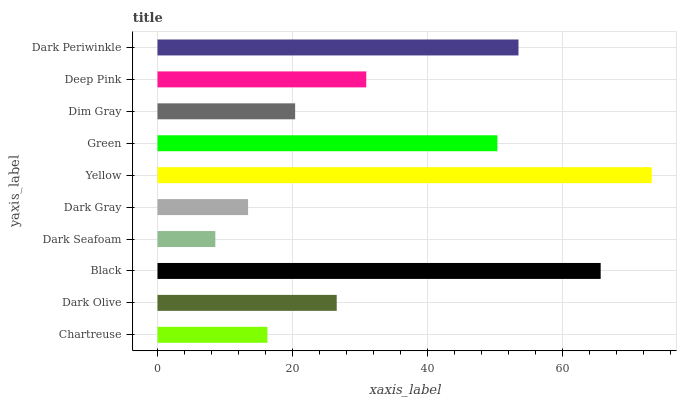Is Dark Seafoam the minimum?
Answer yes or no. Yes. Is Yellow the maximum?
Answer yes or no. Yes. Is Dark Olive the minimum?
Answer yes or no. No. Is Dark Olive the maximum?
Answer yes or no. No. Is Dark Olive greater than Chartreuse?
Answer yes or no. Yes. Is Chartreuse less than Dark Olive?
Answer yes or no. Yes. Is Chartreuse greater than Dark Olive?
Answer yes or no. No. Is Dark Olive less than Chartreuse?
Answer yes or no. No. Is Deep Pink the high median?
Answer yes or no. Yes. Is Dark Olive the low median?
Answer yes or no. Yes. Is Green the high median?
Answer yes or no. No. Is Dark Gray the low median?
Answer yes or no. No. 